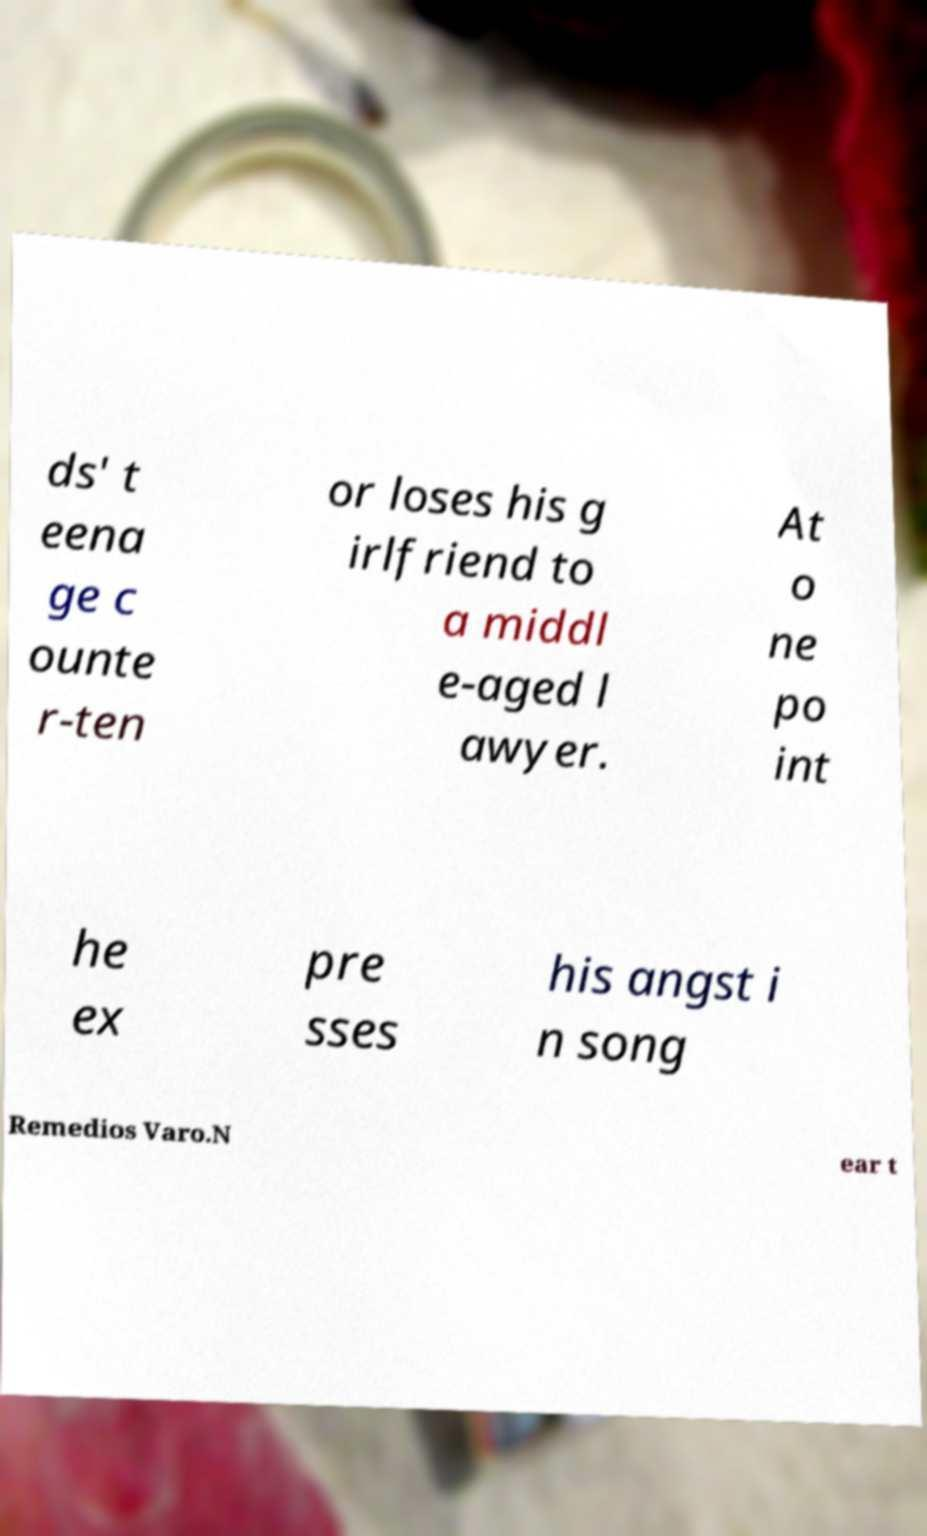There's text embedded in this image that I need extracted. Can you transcribe it verbatim? ds' t eena ge c ounte r-ten or loses his g irlfriend to a middl e-aged l awyer. At o ne po int he ex pre sses his angst i n song Remedios Varo.N ear t 